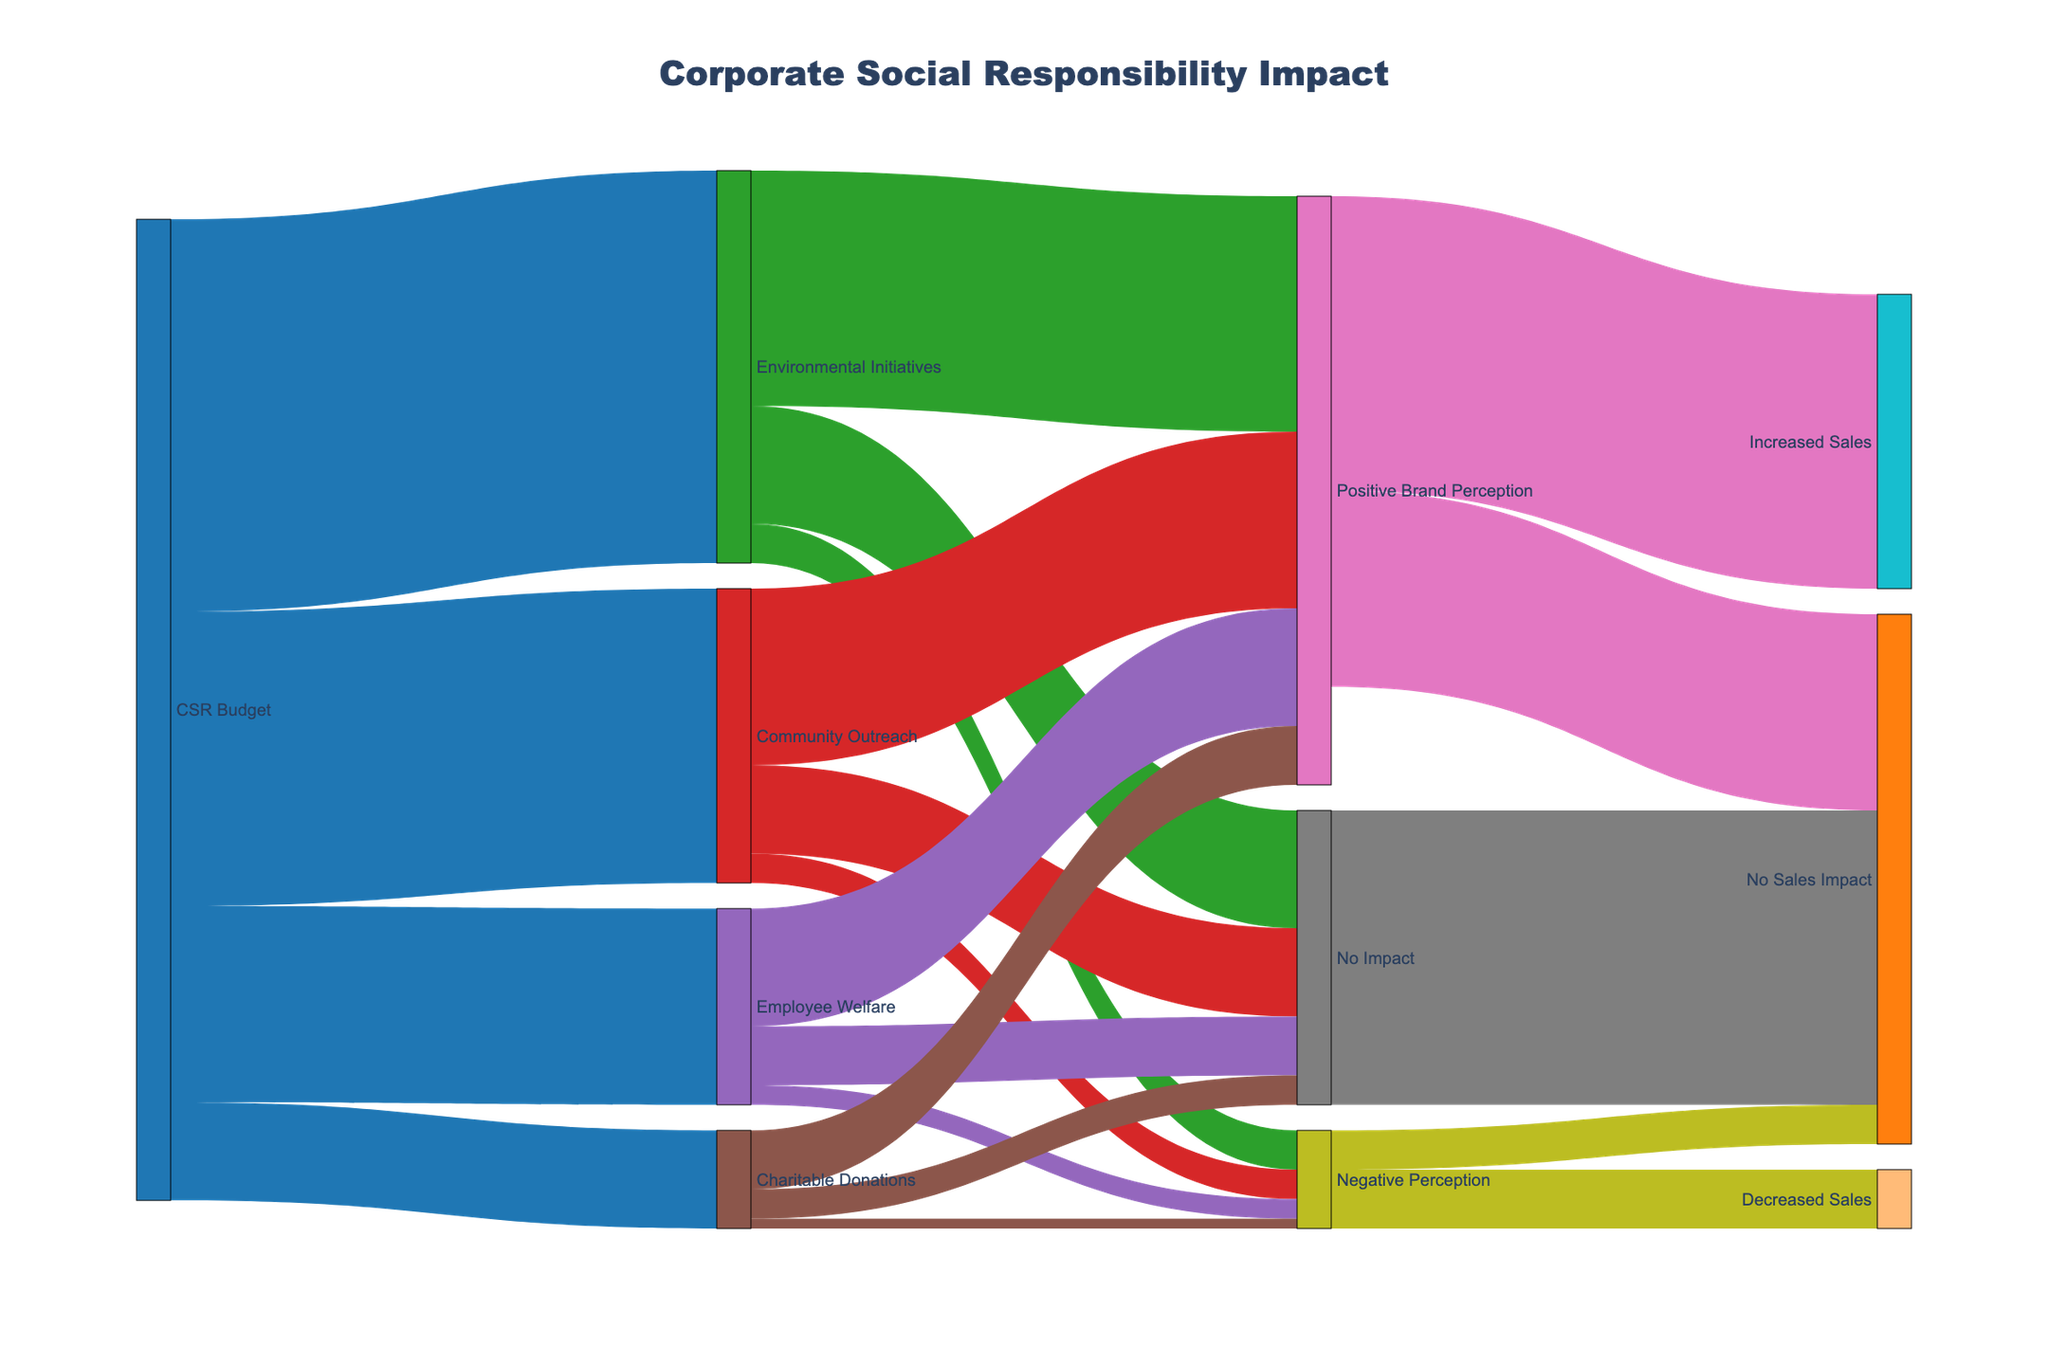What's the largest allocation of the CSR Budget? The largest allocation is shown by the widest band originating from the CSR Budget node, which is directed towards Environmental Initiatives with a value of 2,000,000.
Answer: Environmental Initiatives How much of the CSR budget was allocated to Community Outreach? The Community Outreach node receives a band from the CSR Budget node, which is labeled with a value of 1,500,000.
Answer: 1,500,000 What percentage of the CSR budget was assigned to Employee Welfare? The Employee Welfare allocation is 1,000,000. The total CSR Budget is 5,000,000 (sum of all allocations). The percentage is calculated as (1,000,000 / 5,000,000) * 100%.
Answer: 20% Which CSR initiative had the least positive effect on brand perception? Comparing the widths and values of bands leading to Positive Brand Perception from different CSR activities, Charitable Donations had the least with a value of 300,000.
Answer: Charitable Donations How much total budget was spent on activities that had either no impact or a negative perception on the brand? Summing up no impact and negative perception values: Environmental Initiatives (600,000 + 200,000), Community Outreach (450,000 + 150,000), Employee Welfare (300,000 + 100,000), and Charitable Donations (150,000 + 50,000). Total is (800,000 + 600,000 + 400,000 + 200,000) = 2,000,000.
Answer: 2,000,000 What is the total amount of sales impacted by positive brand perception? Summing up bands directed from Positive Brand Perception to Increased Sales (1,500,000) and No Sales Impact (1,000,000): 1,500,000 + 1,000,000.
Answer: 2,500,000 Compare the total impact on sales due to negative perception versus positive perception. Negative impact on sales sums from links: Decreased Sales (300,000) + No Sales Impact (200,000) is 500,000. 
Positive perception results in Increased Sales (1,500,000) + No Sales Impact (1,000,000) is 2,500,000.
Comparing these two, positive perception results in higher sales impact by (2,500,000 - 500,000).
Answer: 2,000,000 higher What CSR initiative contributed most to increased sales? The path analysis from each CSR initiative to Increased Sales shows Environmental Initiatives contributing the most through Positive Brand Perception, summing up to (1,200,000 of which 1,500,000 was increased sales, major chunk).
Answer: Environmental Initiatives How many budget allocations resulted in no sales impact? Path analysis indicates no sales impact originating from Positive Brand Perception (1), No Impact in perception (1), and Negative Perception (1), totaling 3 allocations resulting in no sales impact.
Answer: 3 